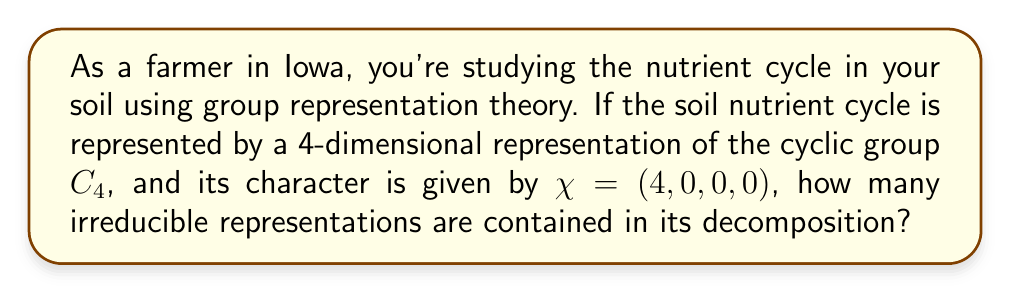Teach me how to tackle this problem. Let's approach this step-by-step:

1) For a cyclic group $C_4$, there are four irreducible representations, typically denoted as $\rho_0, \rho_1, \rho_2, \rho_3$.

2) The character table for $C_4$ is:

   $$\begin{array}{c|cccc}
   C_4 & e & g & g^2 & g^3 \\
   \hline
   \rho_0 & 1 & 1 & 1 & 1 \\
   \rho_1 & 1 & i & -1 & -i \\
   \rho_2 & 1 & -1 & 1 & -1 \\
   \rho_3 & 1 & -i & -1 & i
   \end{array}$$

3) Our representation $\chi$ has character $(4, 0, 0, 0)$.

4) To decompose $\chi$, we need to find how many times each irreducible representation appears. We can do this using the inner product of characters:

   $$\langle \chi, \rho_i \rangle = \frac{1}{|G|} \sum_{g \in G} \chi(g) \overline{\rho_i(g)}$$

5) For $\rho_0$: 
   $$\langle \chi, \rho_0 \rangle = \frac{1}{4}(4 \cdot 1 + 0 \cdot 1 + 0 \cdot 1 + 0 \cdot 1) = 1$$

6) For $\rho_1, \rho_2, \rho_3$:
   $$\langle \chi, \rho_i \rangle = \frac{1}{4}(4 \cdot 1 + 0 \cdot x + 0 \cdot y + 0 \cdot z) = 1$$
   (where $x, y, z$ are the appropriate values from the character table)

7) Therefore, each irreducible representation appears exactly once in the decomposition of $\chi$.

8) The total number of irreducible representations in the decomposition is 4.
Answer: 4 